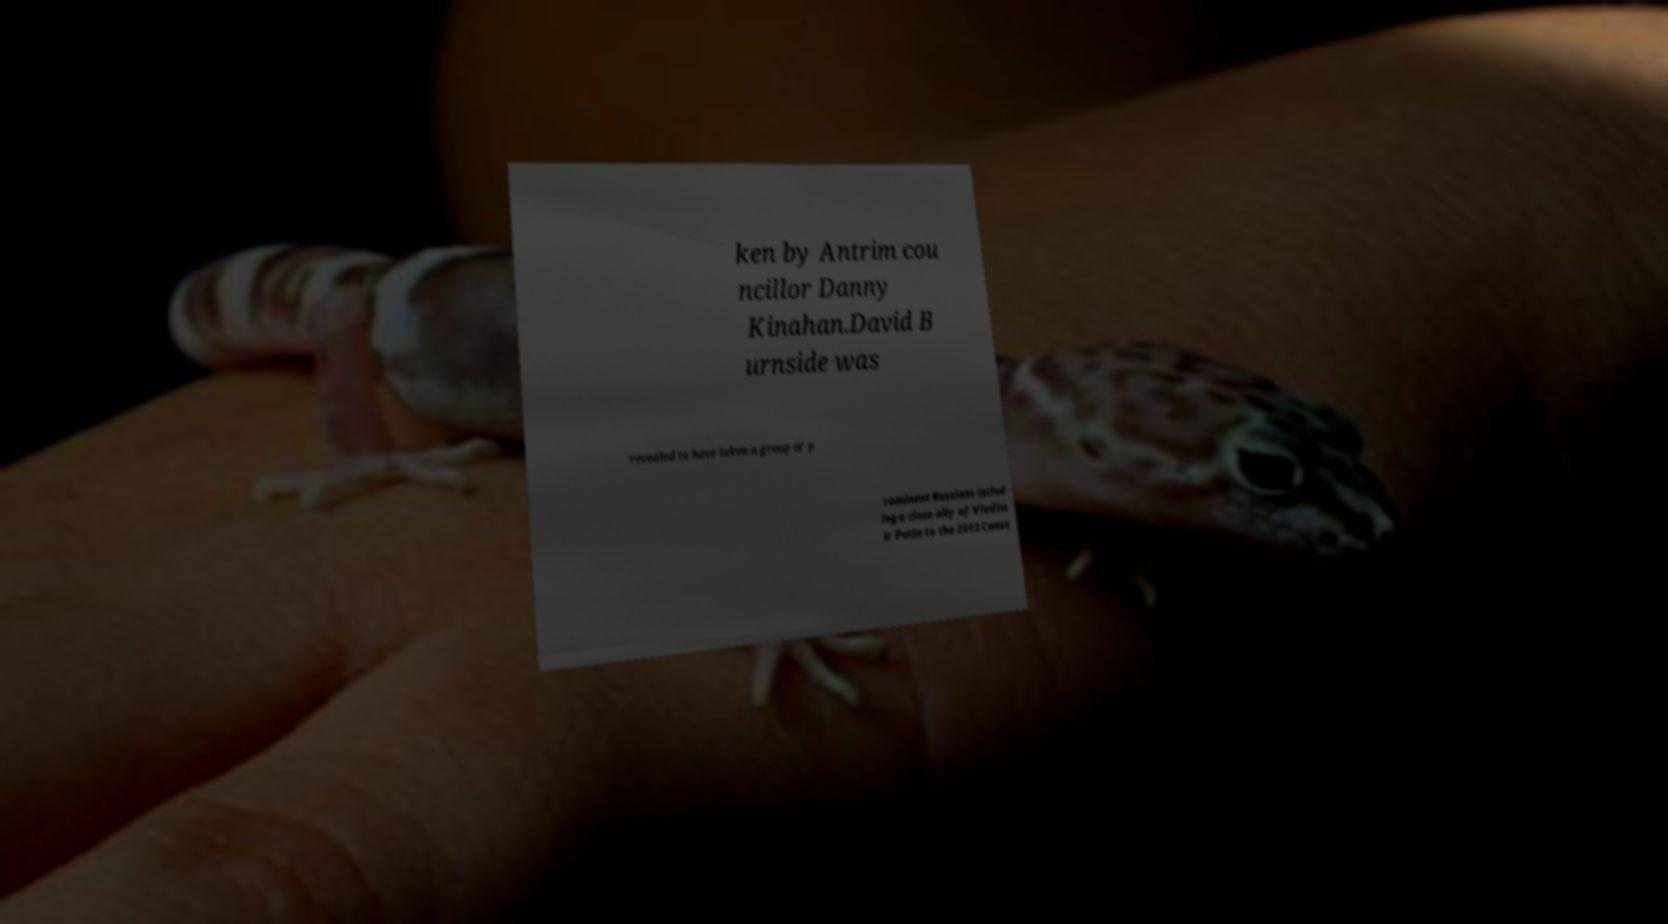What messages or text are displayed in this image? I need them in a readable, typed format. ken by Antrim cou ncillor Danny Kinahan.David B urnside was revealed to have taken a group of p rominent Russians includ ing a close ally of Vladim ir Putin to the 2013 Conse 